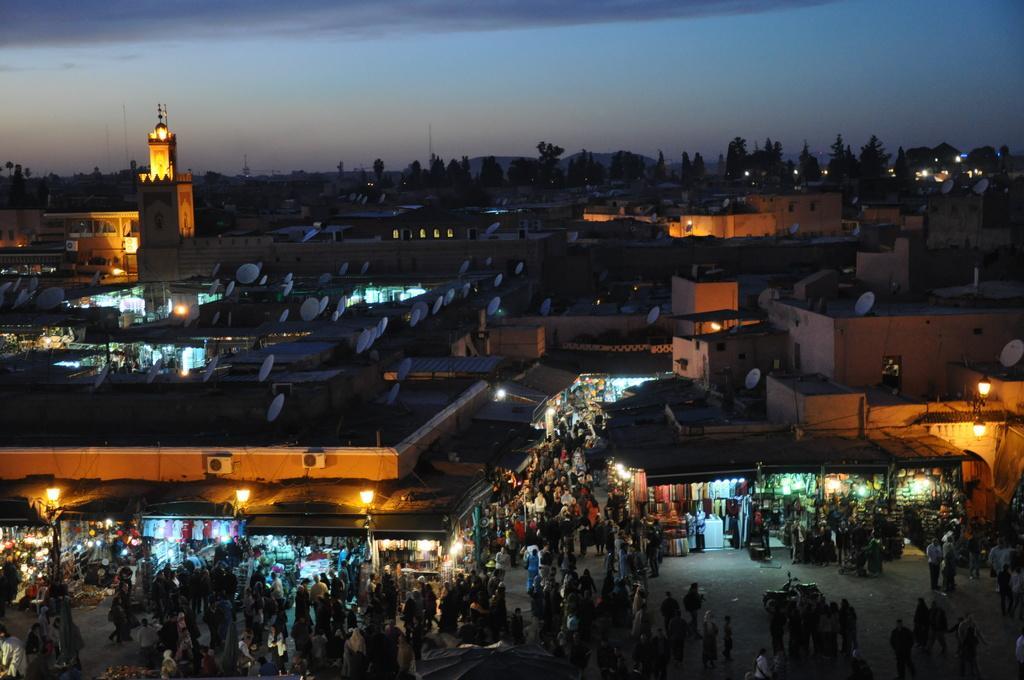How would you summarize this image in a sentence or two? Here we can see people and we can see stalls and lights. We can see houses and dish antenna. Background we can see trees and sky. 